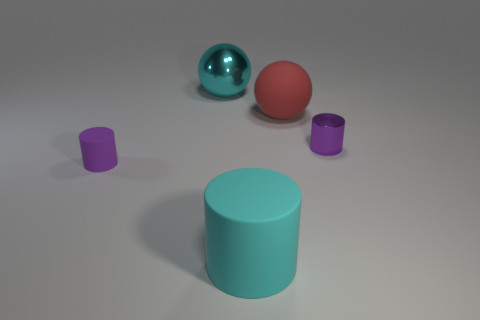Is there a big metal sphere of the same color as the big cylinder?
Give a very brief answer. Yes. What number of small purple objects are in front of the cyan object that is in front of the tiny purple matte thing that is in front of the big red rubber thing?
Make the answer very short. 0. There is a cyan matte cylinder; what number of cyan things are behind it?
Offer a terse response. 1. There is a big sphere behind the matte thing behind the purple rubber object; what color is it?
Ensure brevity in your answer.  Cyan. How many other objects are the same material as the cyan sphere?
Offer a terse response. 1. Are there the same number of large cylinders behind the large metallic thing and tiny gray rubber cylinders?
Make the answer very short. Yes. There is a tiny purple cylinder that is to the right of the large ball that is behind the rubber thing that is behind the small purple metallic cylinder; what is its material?
Offer a very short reply. Metal. There is a big sphere that is to the right of the cyan rubber cylinder; what is its color?
Make the answer very short. Red. What size is the cyan thing in front of the ball that is to the left of the large cyan rubber cylinder?
Your response must be concise. Large. Are there an equal number of large rubber spheres that are to the left of the large cyan shiny sphere and cylinders behind the cyan matte cylinder?
Give a very brief answer. No. 